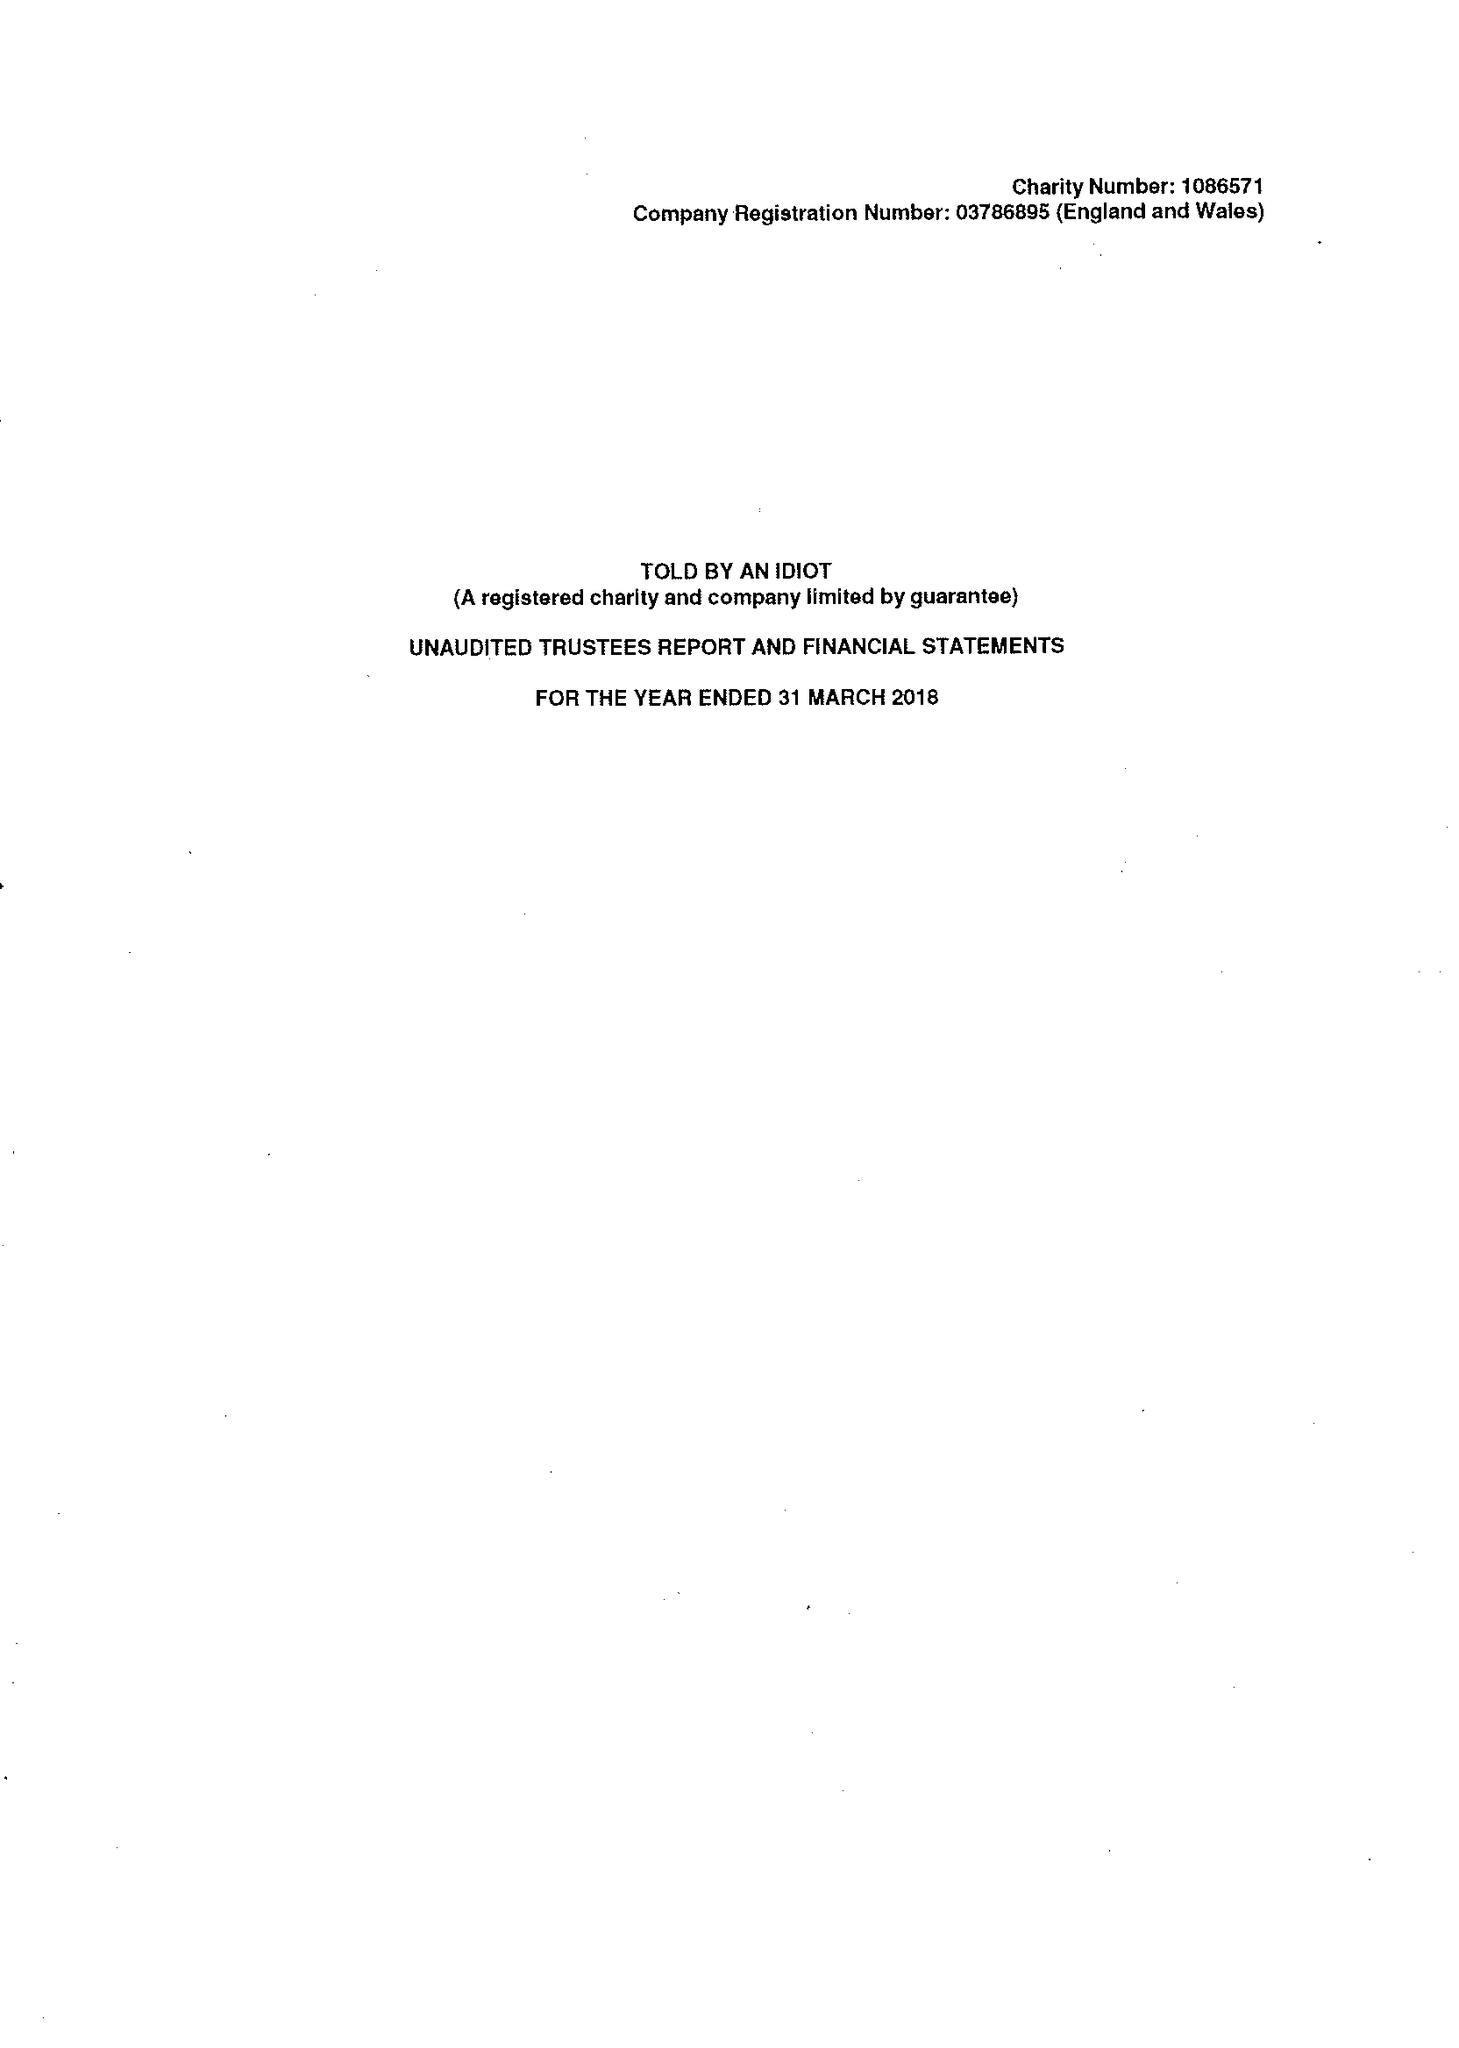What is the value for the report_date?
Answer the question using a single word or phrase. 2018-03-31 